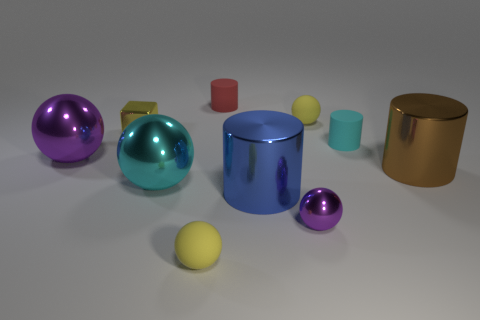Subtract all small red cylinders. How many cylinders are left? 3 Subtract all purple spheres. How many spheres are left? 3 Subtract all cylinders. How many objects are left? 6 Subtract 1 cubes. How many cubes are left? 0 Subtract all cyan spheres. How many brown cubes are left? 0 Add 2 large cyan metal balls. How many large cyan metal balls are left? 3 Add 9 red objects. How many red objects exist? 10 Subtract 1 purple spheres. How many objects are left? 9 Subtract all green cubes. Subtract all cyan balls. How many cubes are left? 1 Subtract all tiny green blocks. Subtract all small red things. How many objects are left? 9 